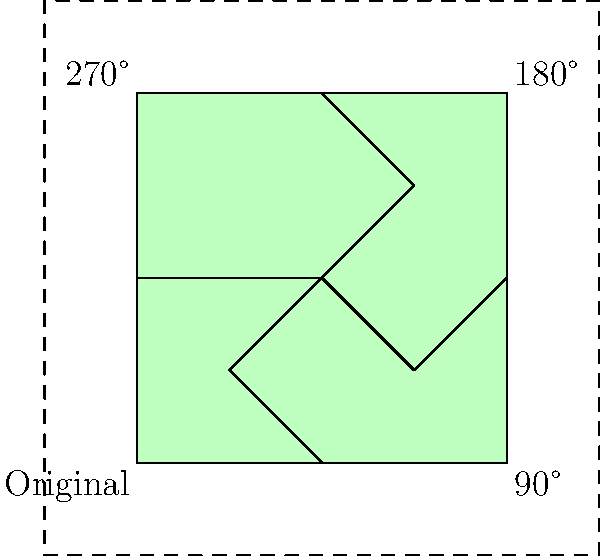In the context of creating a neighborhood scene for dramatic play, a simple house shape is rotated around a central point to form a community. If the original house is at the bottom-left corner, what is the total rotation angle needed to place the fourth house in the top-left corner of the scene? To solve this problem, let's follow these steps:

1. Observe the given diagram, which shows four houses arranged in a square pattern.
2. Note that the original house is in the bottom-left corner.
3. The houses are rotated clockwise around the center point of the square.
4. Each rotation moves the house to the next corner of the square.
5. The rotations are labeled in the diagram:
   - The house in the bottom-right corner is rotated 90°
   - The house in the top-right corner is rotated 180°
   - The house in the top-left corner (our target) is rotated 270°
6. Therefore, to place the fourth house in the top-left corner, we need to rotate the original house by 270°.

This rotation creates a neighborhood scene that could be used in dramatic play to represent different houses in a community, encouraging children to imagine various scenarios and roles within their play environment.
Answer: 270° 